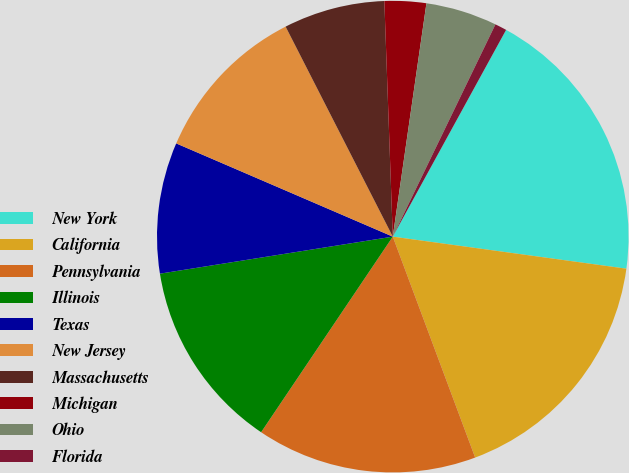Convert chart. <chart><loc_0><loc_0><loc_500><loc_500><pie_chart><fcel>New York<fcel>California<fcel>Pennsylvania<fcel>Illinois<fcel>Texas<fcel>New Jersey<fcel>Massachusetts<fcel>Michigan<fcel>Ohio<fcel>Florida<nl><fcel>19.19%<fcel>17.15%<fcel>15.11%<fcel>13.06%<fcel>8.98%<fcel>11.02%<fcel>6.94%<fcel>2.85%<fcel>4.89%<fcel>0.81%<nl></chart> 